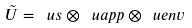Convert formula to latex. <formula><loc_0><loc_0><loc_500><loc_500>\tilde { U } = \ u s \otimes \ u a p p \otimes \ u e n v</formula> 